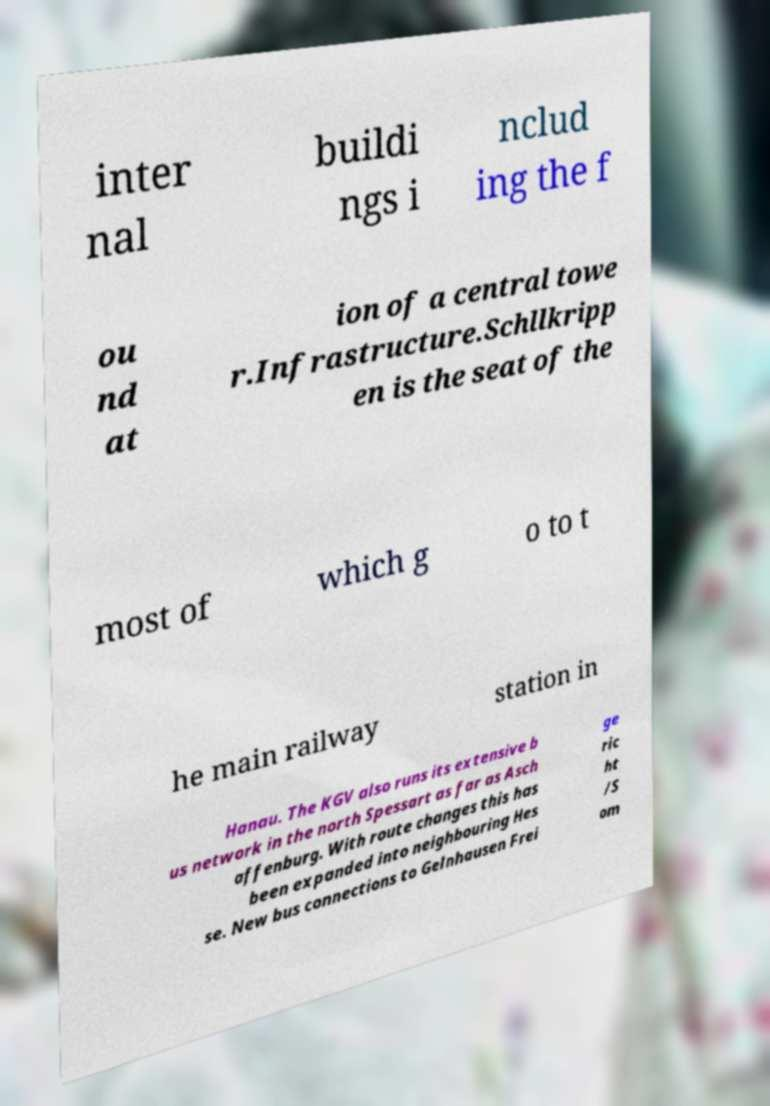Could you extract and type out the text from this image? inter nal buildi ngs i nclud ing the f ou nd at ion of a central towe r.Infrastructure.Schllkripp en is the seat of the most of which g o to t he main railway station in Hanau. The KGV also runs its extensive b us network in the north Spessart as far as Asch affenburg. With route changes this has been expanded into neighbouring Hes se. New bus connections to Gelnhausen Frei ge ric ht /S om 